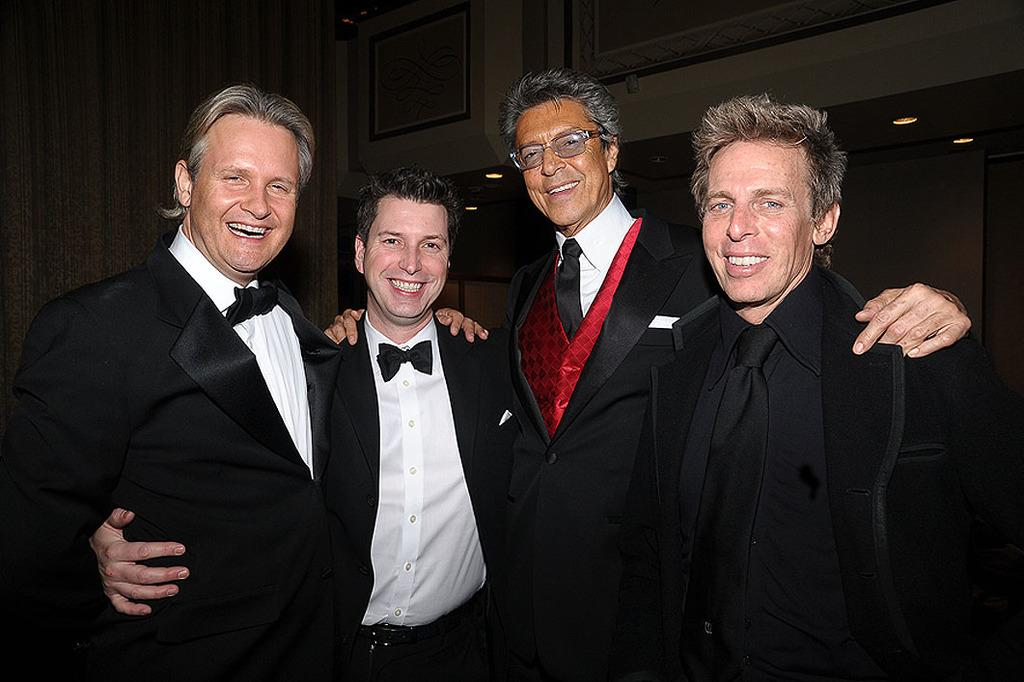How many people are in the image? There is a group of people in the image. What are the people wearing in the image? The people are wearing coats. Can you describe any specific accessories worn by one of the people? One person is wearing spectacles. What can be seen in the background of the image? There are frames on the wall and a group of lights in the background. What type of horse can be seen in the image? There is no horse present in the image. What time of day is it in the image? The provided facts do not give any information about the time of day, so it cannot be determined from the image. 